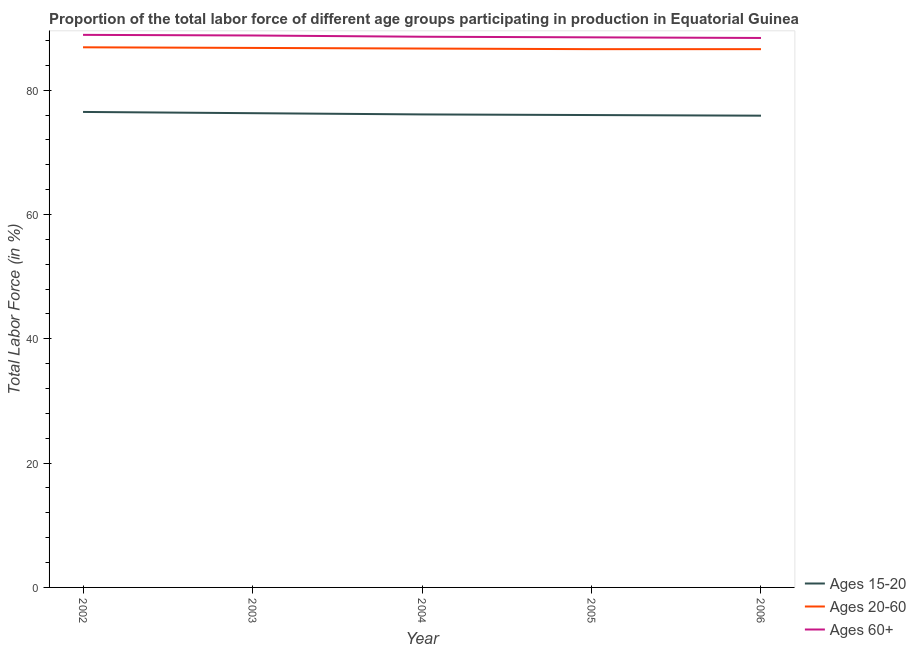How many different coloured lines are there?
Offer a very short reply. 3. Does the line corresponding to percentage of labor force within the age group 15-20 intersect with the line corresponding to percentage of labor force above age 60?
Provide a succinct answer. No. What is the percentage of labor force above age 60 in 2002?
Keep it short and to the point. 88.9. Across all years, what is the maximum percentage of labor force above age 60?
Give a very brief answer. 88.9. Across all years, what is the minimum percentage of labor force within the age group 15-20?
Keep it short and to the point. 75.9. What is the total percentage of labor force above age 60 in the graph?
Ensure brevity in your answer.  443.2. What is the difference between the percentage of labor force within the age group 20-60 in 2003 and that in 2006?
Offer a very short reply. 0.2. What is the difference between the percentage of labor force within the age group 15-20 in 2003 and the percentage of labor force within the age group 20-60 in 2002?
Offer a terse response. -10.6. What is the average percentage of labor force within the age group 15-20 per year?
Provide a succinct answer. 76.16. In how many years, is the percentage of labor force above age 60 greater than 64 %?
Offer a terse response. 5. What is the ratio of the percentage of labor force above age 60 in 2005 to that in 2006?
Your answer should be very brief. 1. Is the percentage of labor force within the age group 20-60 in 2003 less than that in 2004?
Provide a short and direct response. No. Is the difference between the percentage of labor force within the age group 15-20 in 2004 and 2005 greater than the difference between the percentage of labor force above age 60 in 2004 and 2005?
Your response must be concise. No. What is the difference between the highest and the second highest percentage of labor force above age 60?
Offer a very short reply. 0.1. What is the difference between the highest and the lowest percentage of labor force within the age group 15-20?
Give a very brief answer. 0.6. In how many years, is the percentage of labor force within the age group 20-60 greater than the average percentage of labor force within the age group 20-60 taken over all years?
Your answer should be very brief. 2. Is the sum of the percentage of labor force above age 60 in 2003 and 2004 greater than the maximum percentage of labor force within the age group 20-60 across all years?
Make the answer very short. Yes. Is it the case that in every year, the sum of the percentage of labor force within the age group 15-20 and percentage of labor force within the age group 20-60 is greater than the percentage of labor force above age 60?
Your answer should be very brief. Yes. Does the percentage of labor force above age 60 monotonically increase over the years?
Offer a very short reply. No. How many lines are there?
Provide a short and direct response. 3. How many years are there in the graph?
Provide a succinct answer. 5. Does the graph contain grids?
Provide a short and direct response. No. Where does the legend appear in the graph?
Provide a succinct answer. Bottom right. What is the title of the graph?
Provide a short and direct response. Proportion of the total labor force of different age groups participating in production in Equatorial Guinea. What is the label or title of the X-axis?
Offer a very short reply. Year. What is the Total Labor Force (in %) of Ages 15-20 in 2002?
Ensure brevity in your answer.  76.5. What is the Total Labor Force (in %) in Ages 20-60 in 2002?
Offer a very short reply. 86.9. What is the Total Labor Force (in %) in Ages 60+ in 2002?
Your answer should be compact. 88.9. What is the Total Labor Force (in %) of Ages 15-20 in 2003?
Provide a succinct answer. 76.3. What is the Total Labor Force (in %) in Ages 20-60 in 2003?
Make the answer very short. 86.8. What is the Total Labor Force (in %) of Ages 60+ in 2003?
Provide a succinct answer. 88.8. What is the Total Labor Force (in %) of Ages 15-20 in 2004?
Offer a terse response. 76.1. What is the Total Labor Force (in %) of Ages 20-60 in 2004?
Give a very brief answer. 86.7. What is the Total Labor Force (in %) in Ages 60+ in 2004?
Offer a terse response. 88.6. What is the Total Labor Force (in %) in Ages 20-60 in 2005?
Provide a short and direct response. 86.6. What is the Total Labor Force (in %) in Ages 60+ in 2005?
Your response must be concise. 88.5. What is the Total Labor Force (in %) in Ages 15-20 in 2006?
Ensure brevity in your answer.  75.9. What is the Total Labor Force (in %) of Ages 20-60 in 2006?
Offer a very short reply. 86.6. What is the Total Labor Force (in %) in Ages 60+ in 2006?
Offer a very short reply. 88.4. Across all years, what is the maximum Total Labor Force (in %) of Ages 15-20?
Your answer should be compact. 76.5. Across all years, what is the maximum Total Labor Force (in %) of Ages 20-60?
Make the answer very short. 86.9. Across all years, what is the maximum Total Labor Force (in %) in Ages 60+?
Your answer should be very brief. 88.9. Across all years, what is the minimum Total Labor Force (in %) of Ages 15-20?
Offer a very short reply. 75.9. Across all years, what is the minimum Total Labor Force (in %) in Ages 20-60?
Make the answer very short. 86.6. Across all years, what is the minimum Total Labor Force (in %) in Ages 60+?
Provide a succinct answer. 88.4. What is the total Total Labor Force (in %) of Ages 15-20 in the graph?
Your answer should be compact. 380.8. What is the total Total Labor Force (in %) in Ages 20-60 in the graph?
Ensure brevity in your answer.  433.6. What is the total Total Labor Force (in %) of Ages 60+ in the graph?
Your answer should be compact. 443.2. What is the difference between the Total Labor Force (in %) in Ages 15-20 in 2002 and that in 2003?
Make the answer very short. 0.2. What is the difference between the Total Labor Force (in %) of Ages 20-60 in 2002 and that in 2003?
Provide a short and direct response. 0.1. What is the difference between the Total Labor Force (in %) of Ages 60+ in 2002 and that in 2003?
Your answer should be very brief. 0.1. What is the difference between the Total Labor Force (in %) in Ages 15-20 in 2002 and that in 2004?
Give a very brief answer. 0.4. What is the difference between the Total Labor Force (in %) of Ages 15-20 in 2002 and that in 2005?
Your response must be concise. 0.5. What is the difference between the Total Labor Force (in %) of Ages 60+ in 2002 and that in 2005?
Make the answer very short. 0.4. What is the difference between the Total Labor Force (in %) in Ages 15-20 in 2002 and that in 2006?
Give a very brief answer. 0.6. What is the difference between the Total Labor Force (in %) in Ages 20-60 in 2002 and that in 2006?
Give a very brief answer. 0.3. What is the difference between the Total Labor Force (in %) of Ages 15-20 in 2003 and that in 2004?
Your response must be concise. 0.2. What is the difference between the Total Labor Force (in %) of Ages 20-60 in 2003 and that in 2004?
Keep it short and to the point. 0.1. What is the difference between the Total Labor Force (in %) in Ages 20-60 in 2003 and that in 2006?
Offer a very short reply. 0.2. What is the difference between the Total Labor Force (in %) in Ages 20-60 in 2004 and that in 2005?
Make the answer very short. 0.1. What is the difference between the Total Labor Force (in %) of Ages 60+ in 2004 and that in 2005?
Ensure brevity in your answer.  0.1. What is the difference between the Total Labor Force (in %) in Ages 15-20 in 2005 and that in 2006?
Your response must be concise. 0.1. What is the difference between the Total Labor Force (in %) in Ages 20-60 in 2002 and the Total Labor Force (in %) in Ages 60+ in 2003?
Your answer should be very brief. -1.9. What is the difference between the Total Labor Force (in %) of Ages 15-20 in 2002 and the Total Labor Force (in %) of Ages 60+ in 2004?
Keep it short and to the point. -12.1. What is the difference between the Total Labor Force (in %) in Ages 20-60 in 2002 and the Total Labor Force (in %) in Ages 60+ in 2004?
Make the answer very short. -1.7. What is the difference between the Total Labor Force (in %) of Ages 15-20 in 2002 and the Total Labor Force (in %) of Ages 20-60 in 2005?
Provide a short and direct response. -10.1. What is the difference between the Total Labor Force (in %) of Ages 20-60 in 2002 and the Total Labor Force (in %) of Ages 60+ in 2005?
Offer a very short reply. -1.6. What is the difference between the Total Labor Force (in %) in Ages 15-20 in 2002 and the Total Labor Force (in %) in Ages 60+ in 2006?
Keep it short and to the point. -11.9. What is the difference between the Total Labor Force (in %) in Ages 20-60 in 2002 and the Total Labor Force (in %) in Ages 60+ in 2006?
Make the answer very short. -1.5. What is the difference between the Total Labor Force (in %) in Ages 15-20 in 2003 and the Total Labor Force (in %) in Ages 20-60 in 2004?
Make the answer very short. -10.4. What is the difference between the Total Labor Force (in %) in Ages 20-60 in 2003 and the Total Labor Force (in %) in Ages 60+ in 2004?
Make the answer very short. -1.8. What is the difference between the Total Labor Force (in %) of Ages 15-20 in 2003 and the Total Labor Force (in %) of Ages 20-60 in 2005?
Keep it short and to the point. -10.3. What is the difference between the Total Labor Force (in %) in Ages 20-60 in 2003 and the Total Labor Force (in %) in Ages 60+ in 2005?
Offer a very short reply. -1.7. What is the difference between the Total Labor Force (in %) of Ages 15-20 in 2003 and the Total Labor Force (in %) of Ages 60+ in 2006?
Your response must be concise. -12.1. What is the difference between the Total Labor Force (in %) in Ages 15-20 in 2004 and the Total Labor Force (in %) in Ages 60+ in 2005?
Give a very brief answer. -12.4. What is the difference between the Total Labor Force (in %) in Ages 20-60 in 2004 and the Total Labor Force (in %) in Ages 60+ in 2005?
Make the answer very short. -1.8. What is the difference between the Total Labor Force (in %) of Ages 15-20 in 2004 and the Total Labor Force (in %) of Ages 20-60 in 2006?
Ensure brevity in your answer.  -10.5. What is the difference between the Total Labor Force (in %) of Ages 20-60 in 2004 and the Total Labor Force (in %) of Ages 60+ in 2006?
Your answer should be compact. -1.7. What is the difference between the Total Labor Force (in %) in Ages 15-20 in 2005 and the Total Labor Force (in %) in Ages 20-60 in 2006?
Your response must be concise. -10.6. What is the difference between the Total Labor Force (in %) of Ages 20-60 in 2005 and the Total Labor Force (in %) of Ages 60+ in 2006?
Provide a succinct answer. -1.8. What is the average Total Labor Force (in %) of Ages 15-20 per year?
Keep it short and to the point. 76.16. What is the average Total Labor Force (in %) of Ages 20-60 per year?
Offer a terse response. 86.72. What is the average Total Labor Force (in %) in Ages 60+ per year?
Offer a very short reply. 88.64. In the year 2003, what is the difference between the Total Labor Force (in %) of Ages 15-20 and Total Labor Force (in %) of Ages 20-60?
Provide a short and direct response. -10.5. In the year 2003, what is the difference between the Total Labor Force (in %) of Ages 20-60 and Total Labor Force (in %) of Ages 60+?
Your answer should be very brief. -2. In the year 2004, what is the difference between the Total Labor Force (in %) in Ages 15-20 and Total Labor Force (in %) in Ages 60+?
Provide a succinct answer. -12.5. In the year 2004, what is the difference between the Total Labor Force (in %) of Ages 20-60 and Total Labor Force (in %) of Ages 60+?
Give a very brief answer. -1.9. In the year 2005, what is the difference between the Total Labor Force (in %) of Ages 20-60 and Total Labor Force (in %) of Ages 60+?
Your response must be concise. -1.9. In the year 2006, what is the difference between the Total Labor Force (in %) of Ages 15-20 and Total Labor Force (in %) of Ages 60+?
Offer a very short reply. -12.5. In the year 2006, what is the difference between the Total Labor Force (in %) of Ages 20-60 and Total Labor Force (in %) of Ages 60+?
Your answer should be compact. -1.8. What is the ratio of the Total Labor Force (in %) in Ages 15-20 in 2002 to that in 2003?
Make the answer very short. 1. What is the ratio of the Total Labor Force (in %) in Ages 20-60 in 2002 to that in 2003?
Give a very brief answer. 1. What is the ratio of the Total Labor Force (in %) of Ages 15-20 in 2002 to that in 2004?
Provide a short and direct response. 1.01. What is the ratio of the Total Labor Force (in %) in Ages 60+ in 2002 to that in 2004?
Your answer should be very brief. 1. What is the ratio of the Total Labor Force (in %) in Ages 15-20 in 2002 to that in 2005?
Your response must be concise. 1.01. What is the ratio of the Total Labor Force (in %) of Ages 15-20 in 2002 to that in 2006?
Provide a succinct answer. 1.01. What is the ratio of the Total Labor Force (in %) of Ages 15-20 in 2003 to that in 2004?
Give a very brief answer. 1. What is the ratio of the Total Labor Force (in %) of Ages 20-60 in 2003 to that in 2004?
Keep it short and to the point. 1. What is the ratio of the Total Labor Force (in %) of Ages 60+ in 2003 to that in 2004?
Offer a very short reply. 1. What is the ratio of the Total Labor Force (in %) in Ages 15-20 in 2003 to that in 2005?
Your answer should be compact. 1. What is the ratio of the Total Labor Force (in %) of Ages 60+ in 2003 to that in 2005?
Provide a succinct answer. 1. What is the ratio of the Total Labor Force (in %) in Ages 20-60 in 2003 to that in 2006?
Your answer should be compact. 1. What is the ratio of the Total Labor Force (in %) in Ages 60+ in 2003 to that in 2006?
Keep it short and to the point. 1. What is the ratio of the Total Labor Force (in %) in Ages 15-20 in 2004 to that in 2005?
Keep it short and to the point. 1. What is the ratio of the Total Labor Force (in %) of Ages 60+ in 2004 to that in 2005?
Keep it short and to the point. 1. What is the ratio of the Total Labor Force (in %) of Ages 15-20 in 2004 to that in 2006?
Offer a terse response. 1. What is the ratio of the Total Labor Force (in %) of Ages 60+ in 2004 to that in 2006?
Your answer should be very brief. 1. What is the ratio of the Total Labor Force (in %) of Ages 60+ in 2005 to that in 2006?
Offer a very short reply. 1. What is the difference between the highest and the lowest Total Labor Force (in %) of Ages 15-20?
Your answer should be very brief. 0.6. What is the difference between the highest and the lowest Total Labor Force (in %) in Ages 20-60?
Your answer should be compact. 0.3. 